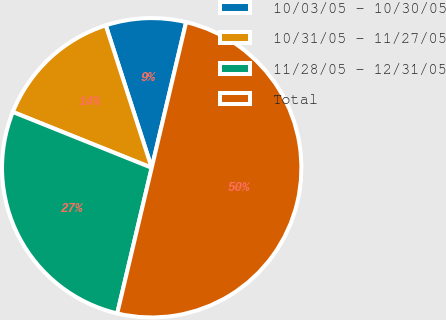Convert chart. <chart><loc_0><loc_0><loc_500><loc_500><pie_chart><fcel>10/03/05 - 10/30/05<fcel>10/31/05 - 11/27/05<fcel>11/28/05 - 12/31/05<fcel>Total<nl><fcel>8.66%<fcel>13.95%<fcel>27.38%<fcel>50.0%<nl></chart> 